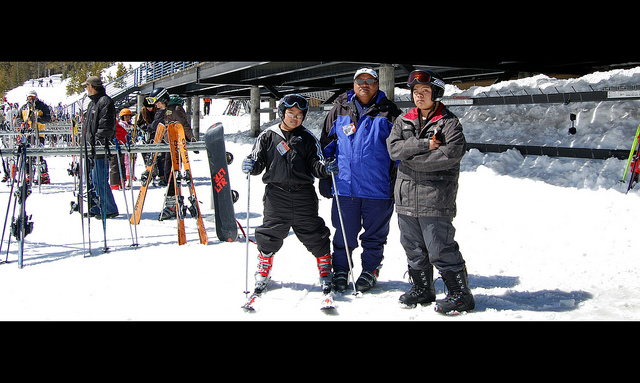How many of the three people are wearing skis? 1 